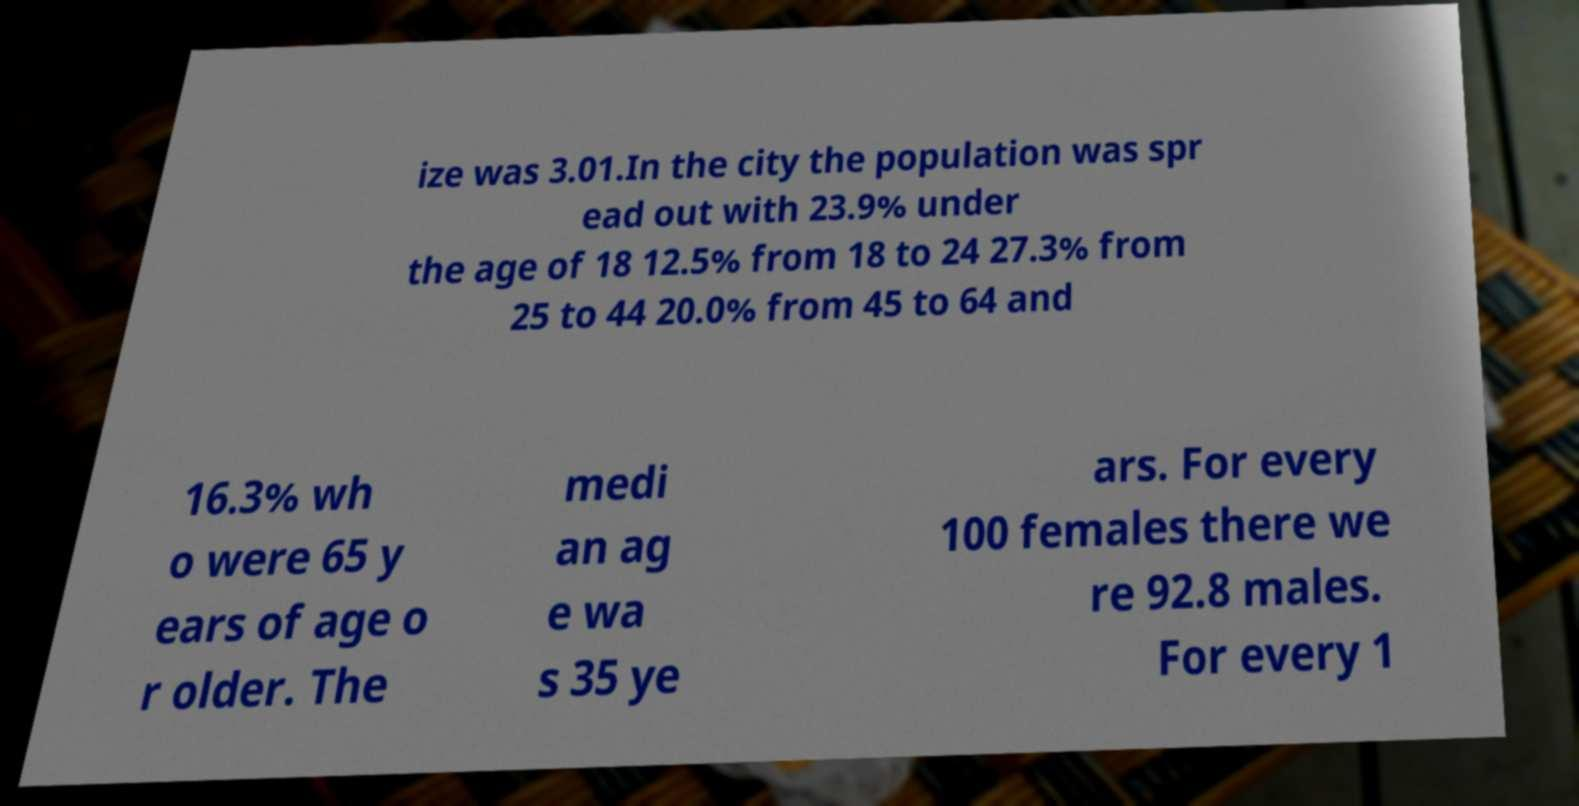What messages or text are displayed in this image? I need them in a readable, typed format. ize was 3.01.In the city the population was spr ead out with 23.9% under the age of 18 12.5% from 18 to 24 27.3% from 25 to 44 20.0% from 45 to 64 and 16.3% wh o were 65 y ears of age o r older. The medi an ag e wa s 35 ye ars. For every 100 females there we re 92.8 males. For every 1 